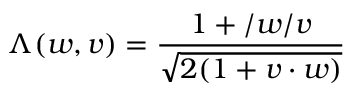<formula> <loc_0><loc_0><loc_500><loc_500>\Lambda ( w , v ) = \frac { 1 + \slash w \slash v } { \sqrt { 2 ( 1 + v \cdot w ) } }</formula> 